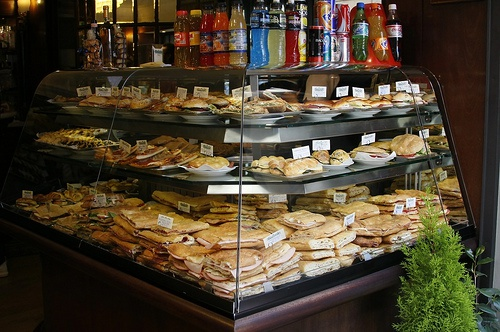Describe the objects in this image and their specific colors. I can see sandwich in black, olive, maroon, and tan tones, potted plant in black, darkgreen, and olive tones, bottle in black, blue, and gray tones, bottle in black, maroon, gray, and brown tones, and bottle in black, olive, gray, and darkgray tones in this image. 